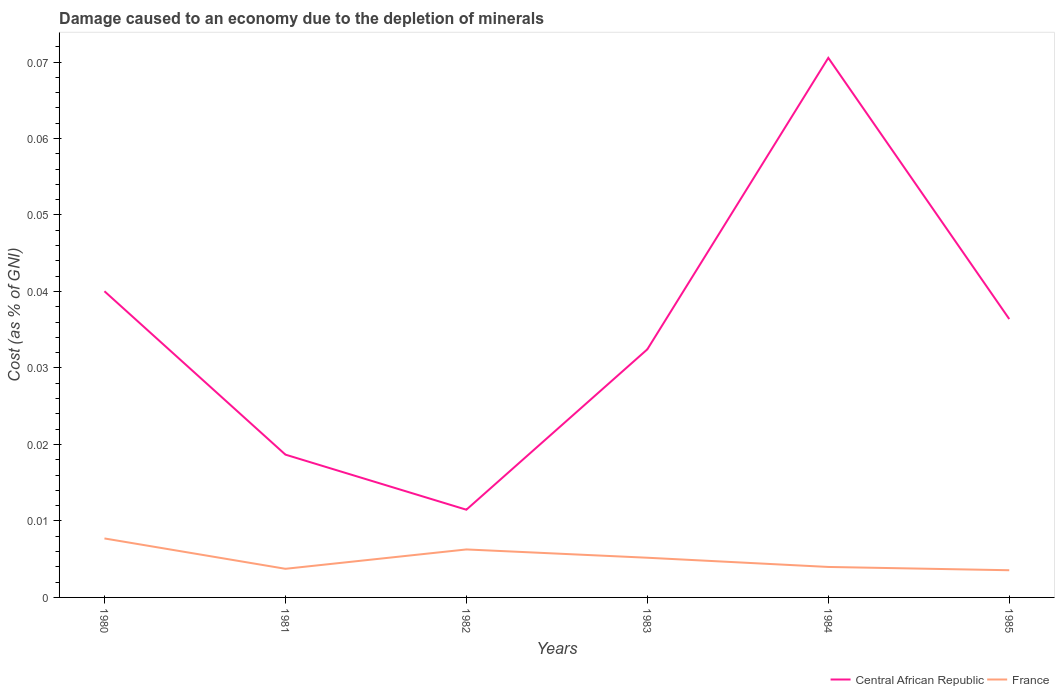Does the line corresponding to Central African Republic intersect with the line corresponding to France?
Offer a terse response. No. Is the number of lines equal to the number of legend labels?
Ensure brevity in your answer.  Yes. Across all years, what is the maximum cost of damage caused due to the depletion of minerals in Central African Republic?
Make the answer very short. 0.01. In which year was the cost of damage caused due to the depletion of minerals in France maximum?
Offer a terse response. 1985. What is the total cost of damage caused due to the depletion of minerals in Central African Republic in the graph?
Give a very brief answer. 0.03. What is the difference between the highest and the second highest cost of damage caused due to the depletion of minerals in France?
Give a very brief answer. 0. Is the cost of damage caused due to the depletion of minerals in France strictly greater than the cost of damage caused due to the depletion of minerals in Central African Republic over the years?
Give a very brief answer. Yes. How many lines are there?
Offer a very short reply. 2. What is the difference between two consecutive major ticks on the Y-axis?
Offer a very short reply. 0.01. Are the values on the major ticks of Y-axis written in scientific E-notation?
Your answer should be compact. No. Does the graph contain any zero values?
Your answer should be very brief. No. How are the legend labels stacked?
Your response must be concise. Horizontal. What is the title of the graph?
Provide a succinct answer. Damage caused to an economy due to the depletion of minerals. What is the label or title of the X-axis?
Offer a terse response. Years. What is the label or title of the Y-axis?
Ensure brevity in your answer.  Cost (as % of GNI). What is the Cost (as % of GNI) of Central African Republic in 1980?
Your answer should be very brief. 0.04. What is the Cost (as % of GNI) of France in 1980?
Make the answer very short. 0.01. What is the Cost (as % of GNI) in Central African Republic in 1981?
Make the answer very short. 0.02. What is the Cost (as % of GNI) in France in 1981?
Provide a short and direct response. 0. What is the Cost (as % of GNI) in Central African Republic in 1982?
Ensure brevity in your answer.  0.01. What is the Cost (as % of GNI) of France in 1982?
Your answer should be very brief. 0.01. What is the Cost (as % of GNI) of Central African Republic in 1983?
Give a very brief answer. 0.03. What is the Cost (as % of GNI) in France in 1983?
Ensure brevity in your answer.  0.01. What is the Cost (as % of GNI) in Central African Republic in 1984?
Your response must be concise. 0.07. What is the Cost (as % of GNI) of France in 1984?
Give a very brief answer. 0. What is the Cost (as % of GNI) of Central African Republic in 1985?
Provide a succinct answer. 0.04. What is the Cost (as % of GNI) of France in 1985?
Offer a very short reply. 0. Across all years, what is the maximum Cost (as % of GNI) in Central African Republic?
Provide a short and direct response. 0.07. Across all years, what is the maximum Cost (as % of GNI) in France?
Give a very brief answer. 0.01. Across all years, what is the minimum Cost (as % of GNI) of Central African Republic?
Make the answer very short. 0.01. Across all years, what is the minimum Cost (as % of GNI) in France?
Give a very brief answer. 0. What is the total Cost (as % of GNI) of Central African Republic in the graph?
Provide a succinct answer. 0.21. What is the total Cost (as % of GNI) of France in the graph?
Ensure brevity in your answer.  0.03. What is the difference between the Cost (as % of GNI) of Central African Republic in 1980 and that in 1981?
Keep it short and to the point. 0.02. What is the difference between the Cost (as % of GNI) in France in 1980 and that in 1981?
Your answer should be very brief. 0. What is the difference between the Cost (as % of GNI) in Central African Republic in 1980 and that in 1982?
Ensure brevity in your answer.  0.03. What is the difference between the Cost (as % of GNI) of France in 1980 and that in 1982?
Your answer should be very brief. 0. What is the difference between the Cost (as % of GNI) in Central African Republic in 1980 and that in 1983?
Provide a short and direct response. 0.01. What is the difference between the Cost (as % of GNI) in France in 1980 and that in 1983?
Ensure brevity in your answer.  0. What is the difference between the Cost (as % of GNI) of Central African Republic in 1980 and that in 1984?
Provide a short and direct response. -0.03. What is the difference between the Cost (as % of GNI) of France in 1980 and that in 1984?
Your answer should be compact. 0. What is the difference between the Cost (as % of GNI) of Central African Republic in 1980 and that in 1985?
Ensure brevity in your answer.  0. What is the difference between the Cost (as % of GNI) in France in 1980 and that in 1985?
Provide a succinct answer. 0. What is the difference between the Cost (as % of GNI) of Central African Republic in 1981 and that in 1982?
Give a very brief answer. 0.01. What is the difference between the Cost (as % of GNI) of France in 1981 and that in 1982?
Ensure brevity in your answer.  -0. What is the difference between the Cost (as % of GNI) of Central African Republic in 1981 and that in 1983?
Offer a terse response. -0.01. What is the difference between the Cost (as % of GNI) of France in 1981 and that in 1983?
Your answer should be compact. -0. What is the difference between the Cost (as % of GNI) of Central African Republic in 1981 and that in 1984?
Your response must be concise. -0.05. What is the difference between the Cost (as % of GNI) in France in 1981 and that in 1984?
Give a very brief answer. -0. What is the difference between the Cost (as % of GNI) in Central African Republic in 1981 and that in 1985?
Provide a short and direct response. -0.02. What is the difference between the Cost (as % of GNI) of France in 1981 and that in 1985?
Give a very brief answer. 0. What is the difference between the Cost (as % of GNI) of Central African Republic in 1982 and that in 1983?
Keep it short and to the point. -0.02. What is the difference between the Cost (as % of GNI) of France in 1982 and that in 1983?
Provide a succinct answer. 0. What is the difference between the Cost (as % of GNI) of Central African Republic in 1982 and that in 1984?
Offer a very short reply. -0.06. What is the difference between the Cost (as % of GNI) of France in 1982 and that in 1984?
Give a very brief answer. 0. What is the difference between the Cost (as % of GNI) in Central African Republic in 1982 and that in 1985?
Offer a terse response. -0.02. What is the difference between the Cost (as % of GNI) of France in 1982 and that in 1985?
Provide a succinct answer. 0. What is the difference between the Cost (as % of GNI) of Central African Republic in 1983 and that in 1984?
Provide a short and direct response. -0.04. What is the difference between the Cost (as % of GNI) in France in 1983 and that in 1984?
Your response must be concise. 0. What is the difference between the Cost (as % of GNI) in Central African Republic in 1983 and that in 1985?
Your answer should be very brief. -0. What is the difference between the Cost (as % of GNI) in France in 1983 and that in 1985?
Your response must be concise. 0. What is the difference between the Cost (as % of GNI) of Central African Republic in 1984 and that in 1985?
Provide a succinct answer. 0.03. What is the difference between the Cost (as % of GNI) of Central African Republic in 1980 and the Cost (as % of GNI) of France in 1981?
Offer a terse response. 0.04. What is the difference between the Cost (as % of GNI) of Central African Republic in 1980 and the Cost (as % of GNI) of France in 1982?
Your response must be concise. 0.03. What is the difference between the Cost (as % of GNI) of Central African Republic in 1980 and the Cost (as % of GNI) of France in 1983?
Offer a very short reply. 0.03. What is the difference between the Cost (as % of GNI) of Central African Republic in 1980 and the Cost (as % of GNI) of France in 1984?
Ensure brevity in your answer.  0.04. What is the difference between the Cost (as % of GNI) in Central African Republic in 1980 and the Cost (as % of GNI) in France in 1985?
Keep it short and to the point. 0.04. What is the difference between the Cost (as % of GNI) in Central African Republic in 1981 and the Cost (as % of GNI) in France in 1982?
Keep it short and to the point. 0.01. What is the difference between the Cost (as % of GNI) in Central African Republic in 1981 and the Cost (as % of GNI) in France in 1983?
Provide a succinct answer. 0.01. What is the difference between the Cost (as % of GNI) in Central African Republic in 1981 and the Cost (as % of GNI) in France in 1984?
Ensure brevity in your answer.  0.01. What is the difference between the Cost (as % of GNI) of Central African Republic in 1981 and the Cost (as % of GNI) of France in 1985?
Provide a short and direct response. 0.02. What is the difference between the Cost (as % of GNI) in Central African Republic in 1982 and the Cost (as % of GNI) in France in 1983?
Offer a terse response. 0.01. What is the difference between the Cost (as % of GNI) in Central African Republic in 1982 and the Cost (as % of GNI) in France in 1984?
Provide a succinct answer. 0.01. What is the difference between the Cost (as % of GNI) in Central African Republic in 1982 and the Cost (as % of GNI) in France in 1985?
Keep it short and to the point. 0.01. What is the difference between the Cost (as % of GNI) of Central African Republic in 1983 and the Cost (as % of GNI) of France in 1984?
Your response must be concise. 0.03. What is the difference between the Cost (as % of GNI) in Central African Republic in 1983 and the Cost (as % of GNI) in France in 1985?
Offer a terse response. 0.03. What is the difference between the Cost (as % of GNI) in Central African Republic in 1984 and the Cost (as % of GNI) in France in 1985?
Provide a succinct answer. 0.07. What is the average Cost (as % of GNI) of Central African Republic per year?
Offer a terse response. 0.03. What is the average Cost (as % of GNI) in France per year?
Your response must be concise. 0.01. In the year 1980, what is the difference between the Cost (as % of GNI) of Central African Republic and Cost (as % of GNI) of France?
Ensure brevity in your answer.  0.03. In the year 1981, what is the difference between the Cost (as % of GNI) of Central African Republic and Cost (as % of GNI) of France?
Provide a succinct answer. 0.01. In the year 1982, what is the difference between the Cost (as % of GNI) of Central African Republic and Cost (as % of GNI) of France?
Make the answer very short. 0.01. In the year 1983, what is the difference between the Cost (as % of GNI) in Central African Republic and Cost (as % of GNI) in France?
Keep it short and to the point. 0.03. In the year 1984, what is the difference between the Cost (as % of GNI) of Central African Republic and Cost (as % of GNI) of France?
Give a very brief answer. 0.07. In the year 1985, what is the difference between the Cost (as % of GNI) in Central African Republic and Cost (as % of GNI) in France?
Make the answer very short. 0.03. What is the ratio of the Cost (as % of GNI) of Central African Republic in 1980 to that in 1981?
Make the answer very short. 2.14. What is the ratio of the Cost (as % of GNI) in France in 1980 to that in 1981?
Provide a succinct answer. 2.06. What is the ratio of the Cost (as % of GNI) in Central African Republic in 1980 to that in 1982?
Ensure brevity in your answer.  3.49. What is the ratio of the Cost (as % of GNI) in France in 1980 to that in 1982?
Make the answer very short. 1.23. What is the ratio of the Cost (as % of GNI) of Central African Republic in 1980 to that in 1983?
Ensure brevity in your answer.  1.23. What is the ratio of the Cost (as % of GNI) of France in 1980 to that in 1983?
Keep it short and to the point. 1.49. What is the ratio of the Cost (as % of GNI) in Central African Republic in 1980 to that in 1984?
Make the answer very short. 0.57. What is the ratio of the Cost (as % of GNI) in France in 1980 to that in 1984?
Your answer should be compact. 1.94. What is the ratio of the Cost (as % of GNI) of Central African Republic in 1980 to that in 1985?
Your answer should be very brief. 1.1. What is the ratio of the Cost (as % of GNI) of France in 1980 to that in 1985?
Ensure brevity in your answer.  2.17. What is the ratio of the Cost (as % of GNI) of Central African Republic in 1981 to that in 1982?
Keep it short and to the point. 1.63. What is the ratio of the Cost (as % of GNI) in France in 1981 to that in 1982?
Provide a short and direct response. 0.6. What is the ratio of the Cost (as % of GNI) in Central African Republic in 1981 to that in 1983?
Provide a short and direct response. 0.58. What is the ratio of the Cost (as % of GNI) in France in 1981 to that in 1983?
Give a very brief answer. 0.72. What is the ratio of the Cost (as % of GNI) of Central African Republic in 1981 to that in 1984?
Offer a terse response. 0.26. What is the ratio of the Cost (as % of GNI) in France in 1981 to that in 1984?
Keep it short and to the point. 0.94. What is the ratio of the Cost (as % of GNI) in Central African Republic in 1981 to that in 1985?
Provide a short and direct response. 0.51. What is the ratio of the Cost (as % of GNI) in France in 1981 to that in 1985?
Offer a terse response. 1.05. What is the ratio of the Cost (as % of GNI) in Central African Republic in 1982 to that in 1983?
Offer a very short reply. 0.35. What is the ratio of the Cost (as % of GNI) in France in 1982 to that in 1983?
Provide a short and direct response. 1.21. What is the ratio of the Cost (as % of GNI) in Central African Republic in 1982 to that in 1984?
Keep it short and to the point. 0.16. What is the ratio of the Cost (as % of GNI) of France in 1982 to that in 1984?
Keep it short and to the point. 1.57. What is the ratio of the Cost (as % of GNI) of Central African Republic in 1982 to that in 1985?
Your response must be concise. 0.32. What is the ratio of the Cost (as % of GNI) in France in 1982 to that in 1985?
Offer a very short reply. 1.76. What is the ratio of the Cost (as % of GNI) in Central African Republic in 1983 to that in 1984?
Provide a short and direct response. 0.46. What is the ratio of the Cost (as % of GNI) of France in 1983 to that in 1984?
Make the answer very short. 1.3. What is the ratio of the Cost (as % of GNI) in Central African Republic in 1983 to that in 1985?
Your answer should be very brief. 0.89. What is the ratio of the Cost (as % of GNI) of France in 1983 to that in 1985?
Provide a short and direct response. 1.46. What is the ratio of the Cost (as % of GNI) in Central African Republic in 1984 to that in 1985?
Ensure brevity in your answer.  1.94. What is the ratio of the Cost (as % of GNI) of France in 1984 to that in 1985?
Keep it short and to the point. 1.12. What is the difference between the highest and the second highest Cost (as % of GNI) in Central African Republic?
Your response must be concise. 0.03. What is the difference between the highest and the second highest Cost (as % of GNI) of France?
Your answer should be very brief. 0. What is the difference between the highest and the lowest Cost (as % of GNI) of Central African Republic?
Offer a terse response. 0.06. What is the difference between the highest and the lowest Cost (as % of GNI) of France?
Ensure brevity in your answer.  0. 